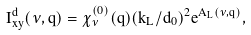Convert formula to latex. <formula><loc_0><loc_0><loc_500><loc_500>I ^ { d } _ { x y } ( \nu , q ) = \chi ^ { ( 0 ) } _ { \nu } ( q ) ( k _ { L } / d _ { 0 } ) ^ { 2 } e ^ { A _ { L } ( \nu , q ) } ,</formula> 